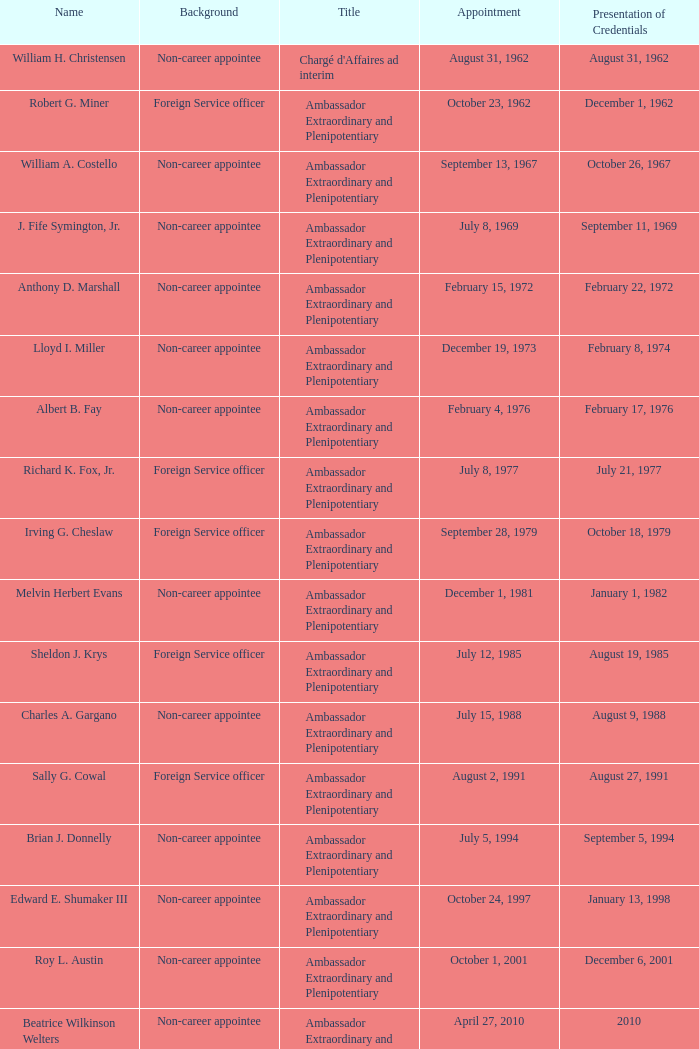When did robert g. miner showcase his credentials? December 1, 1962. 